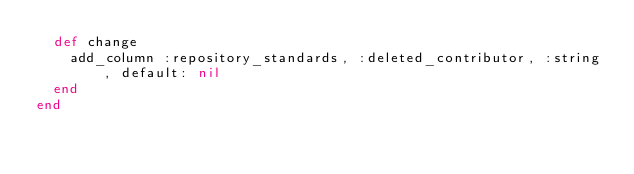Convert code to text. <code><loc_0><loc_0><loc_500><loc_500><_Ruby_>  def change
    add_column :repository_standards, :deleted_contributor, :string, default: nil
  end
end
</code> 